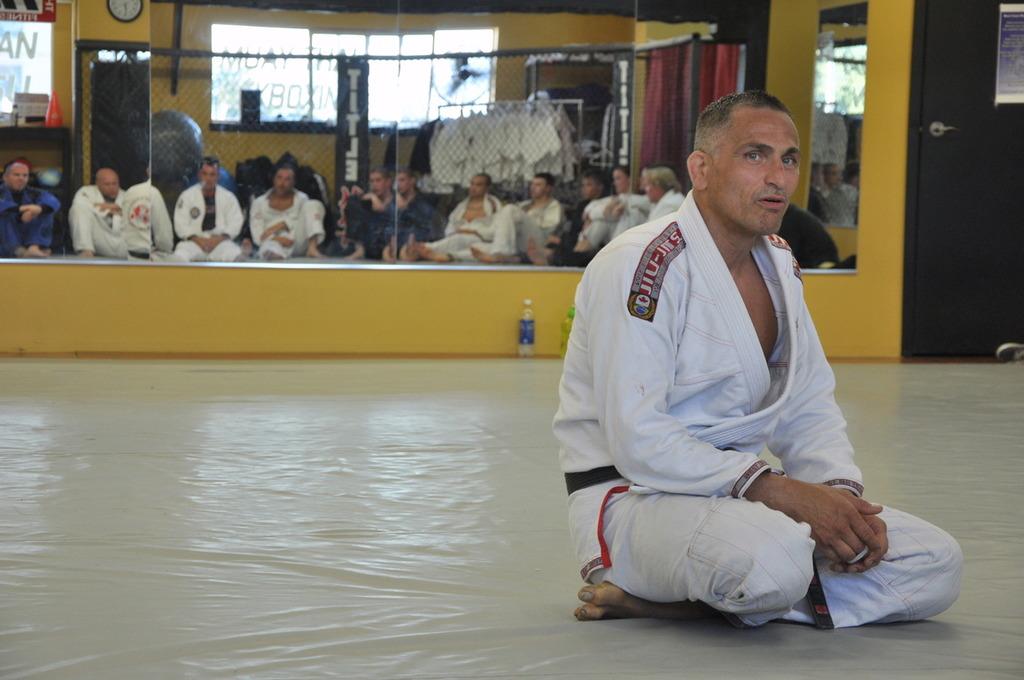What word is written on the black banner?
Ensure brevity in your answer.  Title. 